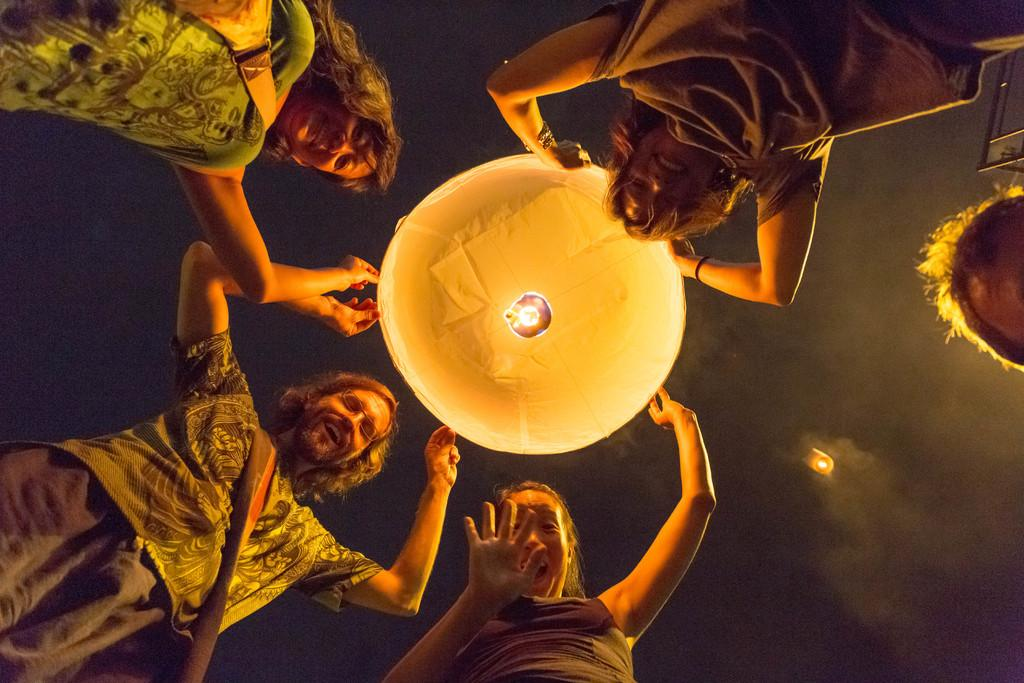What type of objects are in the sky in the image? There are sky lanterns in the image. What expressions do the people in the image have? There are people with smiles in the image. What can be seen in the sky besides the sky lanterns? There are clouds visible in the sky in the image. What type of fruit is being used to write a message on the sky lanterns in the image? There is no fruit, specifically quince, present in the image, and no one is writing a message on the sky lanterns. 